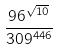Convert formula to latex. <formula><loc_0><loc_0><loc_500><loc_500>\frac { 9 6 ^ { \sqrt { 1 0 } } } { 3 0 9 ^ { 4 4 6 } }</formula> 